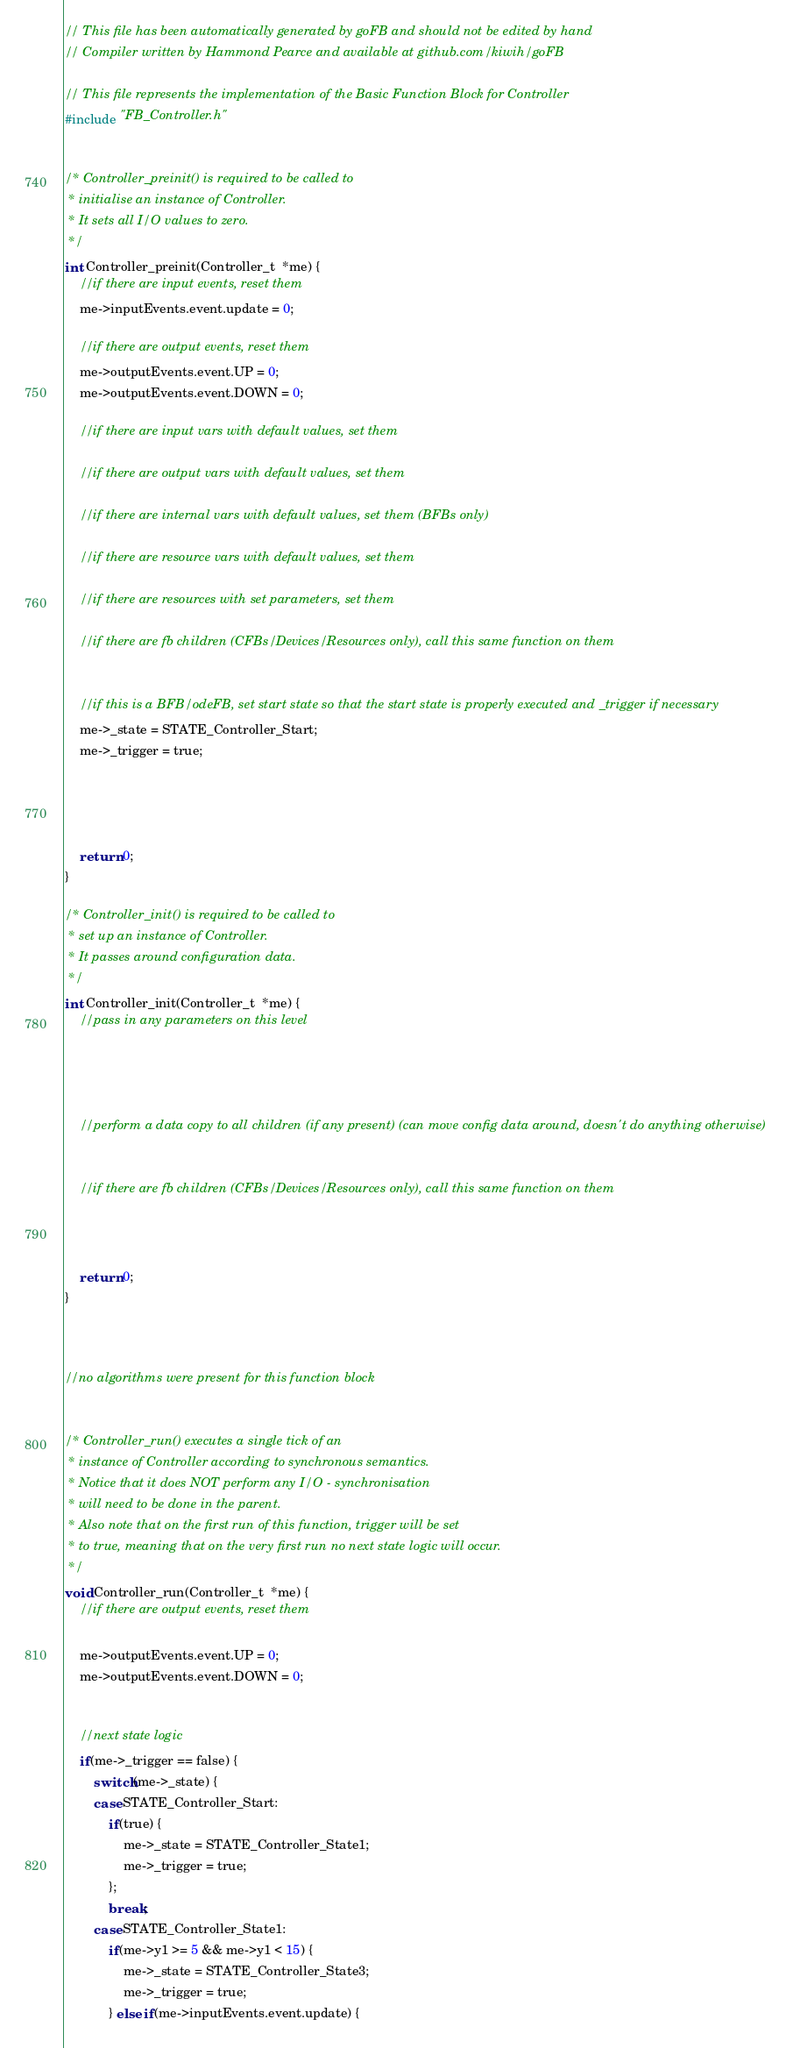<code> <loc_0><loc_0><loc_500><loc_500><_C_>// This file has been automatically generated by goFB and should not be edited by hand
// Compiler written by Hammond Pearce and available at github.com/kiwih/goFB

// This file represents the implementation of the Basic Function Block for Controller
#include "FB_Controller.h"


/* Controller_preinit() is required to be called to 
 * initialise an instance of Controller. 
 * It sets all I/O values to zero.
 */
int Controller_preinit(Controller_t  *me) {
	//if there are input events, reset them
	me->inputEvents.event.update = 0;
	
	//if there are output events, reset them
	me->outputEvents.event.UP = 0;
	me->outputEvents.event.DOWN = 0;
	
	//if there are input vars with default values, set them
	
	//if there are output vars with default values, set them
	
	//if there are internal vars with default values, set them (BFBs only)
	
	//if there are resource vars with default values, set them
	
	//if there are resources with set parameters, set them
	
	//if there are fb children (CFBs/Devices/Resources only), call this same function on them
	
	
	//if this is a BFB/odeFB, set start state so that the start state is properly executed and _trigger if necessary
	me->_state = STATE_Controller_Start;
	me->_trigger = true;
	
	
	

	return 0;
}

/* Controller_init() is required to be called to 
 * set up an instance of Controller. 
 * It passes around configuration data.
 */
int Controller_init(Controller_t  *me) {
	//pass in any parameters on this level
	
	
	

	//perform a data copy to all children (if any present) (can move config data around, doesn't do anything otherwise)
	

	//if there are fb children (CFBs/Devices/Resources only), call this same function on them
	
	

	return 0;
}



//no algorithms were present for this function block


/* Controller_run() executes a single tick of an
 * instance of Controller according to synchronous semantics.
 * Notice that it does NOT perform any I/O - synchronisation
 * will need to be done in the parent.
 * Also note that on the first run of this function, trigger will be set
 * to true, meaning that on the very first run no next state logic will occur.
 */
void Controller_run(Controller_t  *me) {
	//if there are output events, reset them
	
	me->outputEvents.event.UP = 0;
	me->outputEvents.event.DOWN = 0;
	

	//next state logic
	if(me->_trigger == false) {
		switch(me->_state) {
		case STATE_Controller_Start:
			if(true) {
				me->_state = STATE_Controller_State1;
				me->_trigger = true;
			};
			break;
		case STATE_Controller_State1:
			if(me->y1 >= 5 && me->y1 < 15) {
				me->_state = STATE_Controller_State3;
				me->_trigger = true;
			} else if(me->inputEvents.event.update) {</code> 